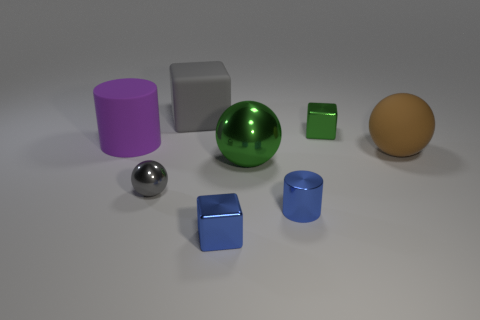Do the large block and the small metallic sphere have the same color?
Ensure brevity in your answer.  Yes. What material is the tiny block behind the green metallic thing in front of the cylinder to the left of the gray ball?
Your answer should be compact. Metal. There is a tiny shiny ball; is its color the same as the rubber object that is behind the small green shiny thing?
Your response must be concise. Yes. How many objects are either tiny cubes in front of the gray metal object or metal cubes that are in front of the big green object?
Your answer should be compact. 1. There is a big matte object that is behind the cylinder that is behind the brown sphere; what shape is it?
Make the answer very short. Cube. Is there a ball that has the same material as the gray block?
Give a very brief answer. Yes. There is a matte thing that is the same shape as the gray shiny thing; what is its color?
Provide a succinct answer. Brown. Are there fewer small blue metal blocks that are in front of the blue block than gray rubber things that are right of the tiny gray metal object?
Provide a short and direct response. Yes. What number of other things are the same shape as the small gray thing?
Offer a terse response. 2. Are there fewer tiny blue metal things that are right of the big brown rubber thing than purple matte balls?
Give a very brief answer. No. 